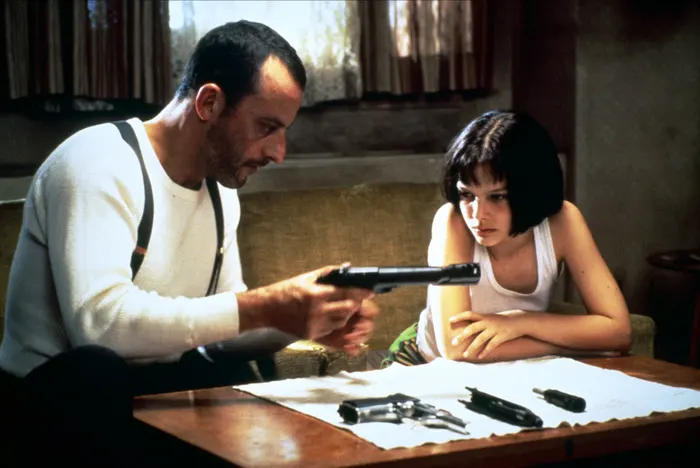Describe the relationship between the two characters in the image. The relationship between the two characters, Léon and Mathilda, is central to the narrative of "Léon: The Professional." Léon, a stoic and skilled hitman, becomes an unlikely mentor and protector to Mathilda, a young girl who has experienced significant trauma. Their relationship evolves from one of necessity into a deep, almost familial bond. Léon teaches Mathilda self-defense and marksmanship as a means of survival, and in return, Mathilda brings a sense of normalcy and emotional connection into Léon's isolated life. What might they be feeling in this moment? In this moment, Léon likely feels a mixture of responsibility and determination as he instructs Mathilda on handling the weapon. His expression and body language indicate a focused and protective mindset. Mathilda appears concerned and intent, suggesting she is taking in Léon's guidance seriously. Beneath her concern, there may be an undercurrent of trust and a desire to learn and be more self-reliant. This scene underscores the gravity of their situation and the depth of their bond. 